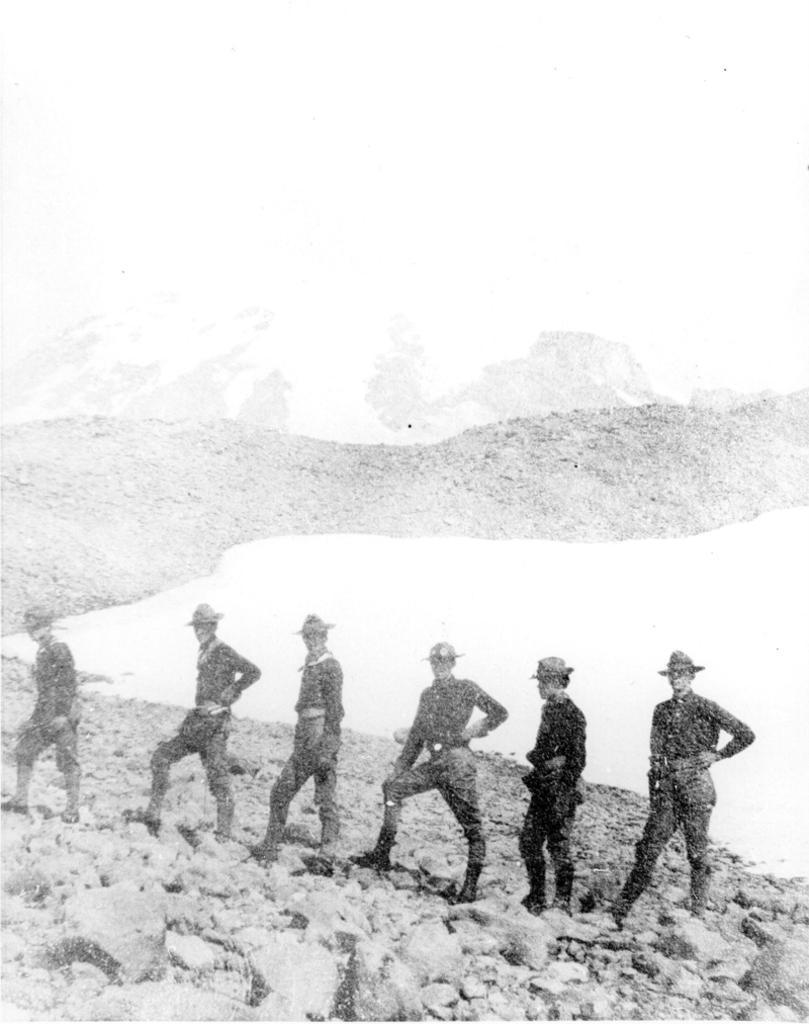How would you summarize this image in a sentence or two? It is the old black and white image in which there are six men who are standing on the stones in the line. 